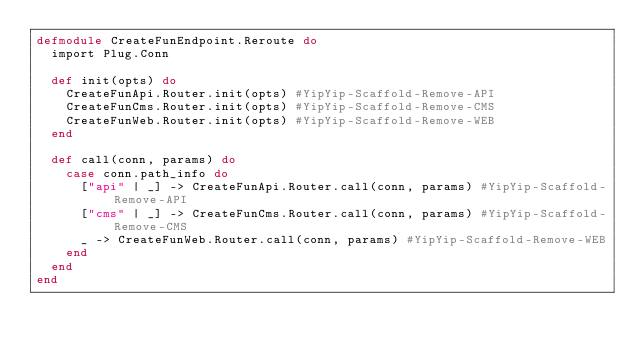Convert code to text. <code><loc_0><loc_0><loc_500><loc_500><_Elixir_>defmodule CreateFunEndpoint.Reroute do
  import Plug.Conn

  def init(opts) do
    CreateFunApi.Router.init(opts) #YipYip-Scaffold-Remove-API
    CreateFunCms.Router.init(opts) #YipYip-Scaffold-Remove-CMS
    CreateFunWeb.Router.init(opts) #YipYip-Scaffold-Remove-WEB
  end

  def call(conn, params) do
    case conn.path_info do
      ["api" | _] -> CreateFunApi.Router.call(conn, params) #YipYip-Scaffold-Remove-API
      ["cms" | _] -> CreateFunCms.Router.call(conn, params) #YipYip-Scaffold-Remove-CMS
      _ -> CreateFunWeb.Router.call(conn, params) #YipYip-Scaffold-Remove-WEB
    end
  end
end
</code> 